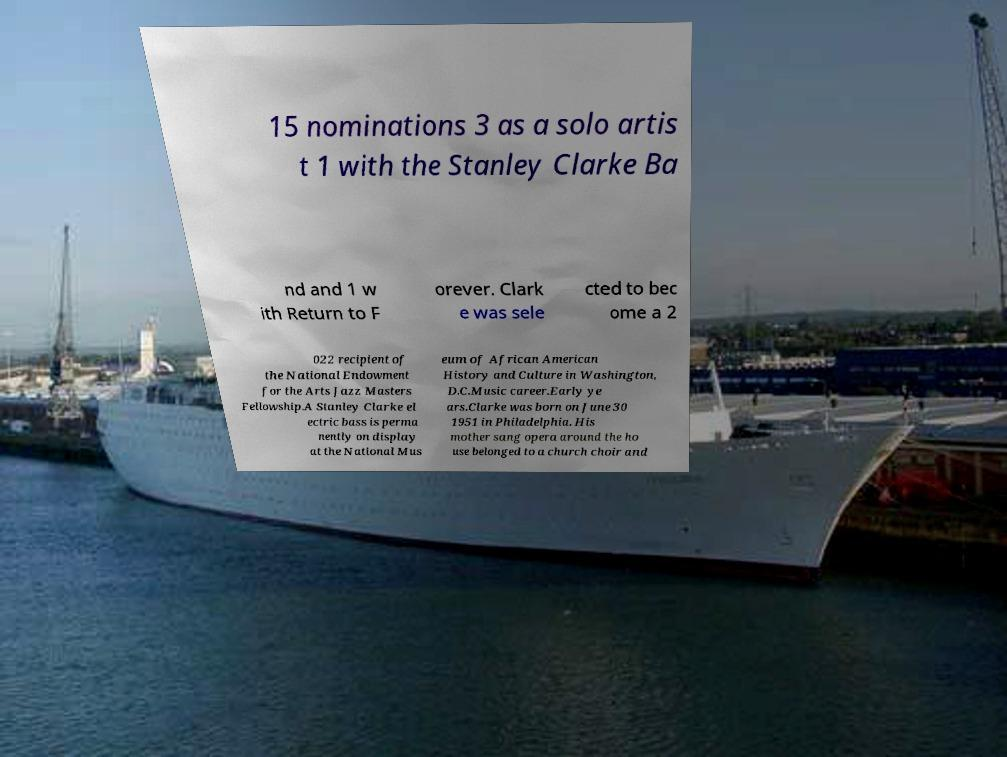Can you read and provide the text displayed in the image?This photo seems to have some interesting text. Can you extract and type it out for me? 15 nominations 3 as a solo artis t 1 with the Stanley Clarke Ba nd and 1 w ith Return to F orever. Clark e was sele cted to bec ome a 2 022 recipient of the National Endowment for the Arts Jazz Masters Fellowship.A Stanley Clarke el ectric bass is perma nently on display at the National Mus eum of African American History and Culture in Washington, D.C.Music career.Early ye ars.Clarke was born on June 30 1951 in Philadelphia. His mother sang opera around the ho use belonged to a church choir and 